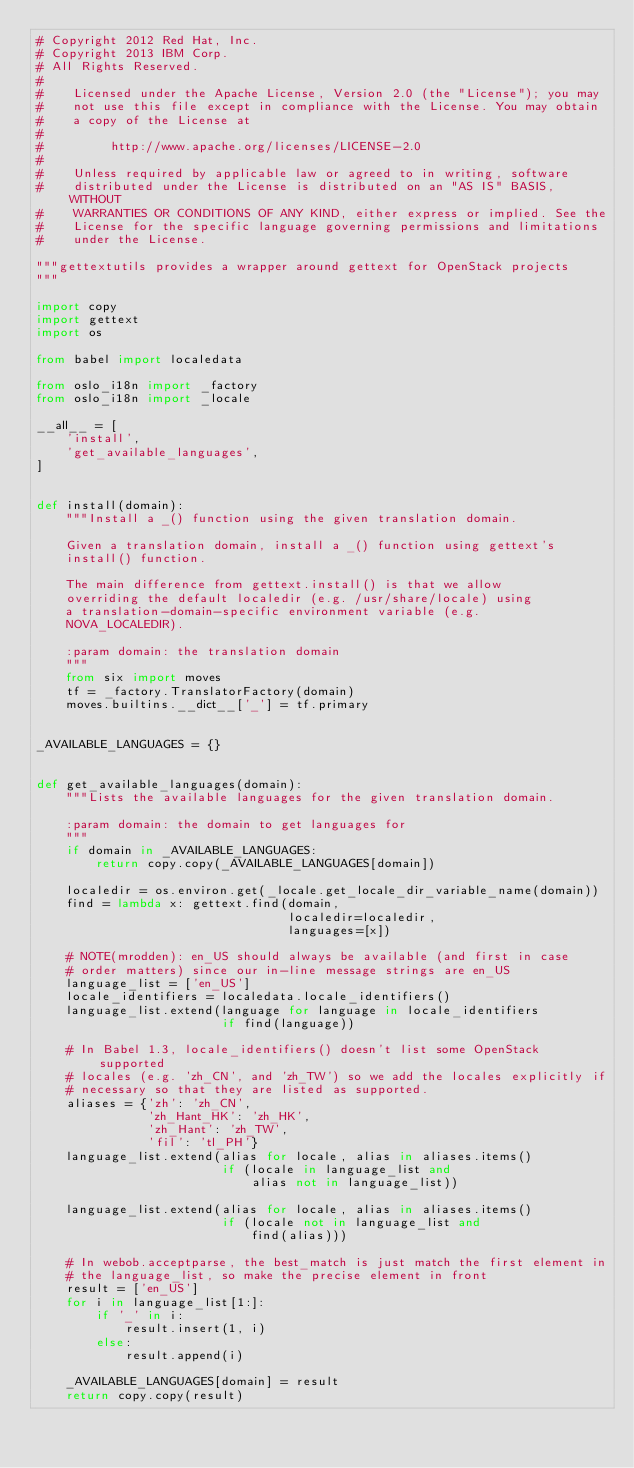Convert code to text. <code><loc_0><loc_0><loc_500><loc_500><_Python_># Copyright 2012 Red Hat, Inc.
# Copyright 2013 IBM Corp.
# All Rights Reserved.
#
#    Licensed under the Apache License, Version 2.0 (the "License"); you may
#    not use this file except in compliance with the License. You may obtain
#    a copy of the License at
#
#         http://www.apache.org/licenses/LICENSE-2.0
#
#    Unless required by applicable law or agreed to in writing, software
#    distributed under the License is distributed on an "AS IS" BASIS, WITHOUT
#    WARRANTIES OR CONDITIONS OF ANY KIND, either express or implied. See the
#    License for the specific language governing permissions and limitations
#    under the License.

"""gettextutils provides a wrapper around gettext for OpenStack projects
"""

import copy
import gettext
import os

from babel import localedata

from oslo_i18n import _factory
from oslo_i18n import _locale

__all__ = [
    'install',
    'get_available_languages',
]


def install(domain):
    """Install a _() function using the given translation domain.

    Given a translation domain, install a _() function using gettext's
    install() function.

    The main difference from gettext.install() is that we allow
    overriding the default localedir (e.g. /usr/share/locale) using
    a translation-domain-specific environment variable (e.g.
    NOVA_LOCALEDIR).

    :param domain: the translation domain
    """
    from six import moves
    tf = _factory.TranslatorFactory(domain)
    moves.builtins.__dict__['_'] = tf.primary


_AVAILABLE_LANGUAGES = {}


def get_available_languages(domain):
    """Lists the available languages for the given translation domain.

    :param domain: the domain to get languages for
    """
    if domain in _AVAILABLE_LANGUAGES:
        return copy.copy(_AVAILABLE_LANGUAGES[domain])

    localedir = os.environ.get(_locale.get_locale_dir_variable_name(domain))
    find = lambda x: gettext.find(domain,
                                  localedir=localedir,
                                  languages=[x])

    # NOTE(mrodden): en_US should always be available (and first in case
    # order matters) since our in-line message strings are en_US
    language_list = ['en_US']
    locale_identifiers = localedata.locale_identifiers()
    language_list.extend(language for language in locale_identifiers
                         if find(language))

    # In Babel 1.3, locale_identifiers() doesn't list some OpenStack supported
    # locales (e.g. 'zh_CN', and 'zh_TW') so we add the locales explicitly if
    # necessary so that they are listed as supported.
    aliases = {'zh': 'zh_CN',
               'zh_Hant_HK': 'zh_HK',
               'zh_Hant': 'zh_TW',
               'fil': 'tl_PH'}
    language_list.extend(alias for locale, alias in aliases.items()
                         if (locale in language_list and
                             alias not in language_list))

    language_list.extend(alias for locale, alias in aliases.items()
                         if (locale not in language_list and
                             find(alias)))

    # In webob.acceptparse, the best_match is just match the first element in
    # the language_list, so make the precise element in front
    result = ['en_US']
    for i in language_list[1:]:
        if '_' in i:
            result.insert(1, i)
        else:
            result.append(i)

    _AVAILABLE_LANGUAGES[domain] = result
    return copy.copy(result)
</code> 